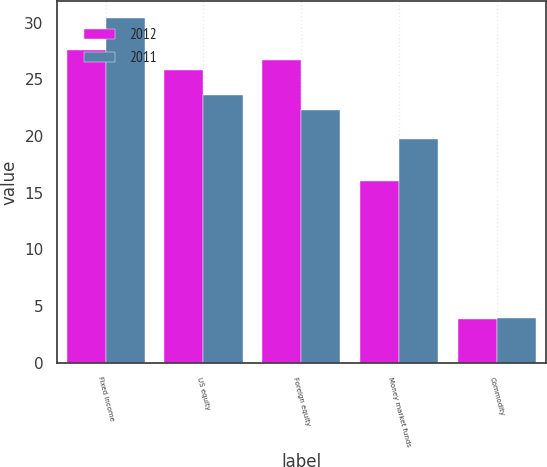Convert chart to OTSL. <chart><loc_0><loc_0><loc_500><loc_500><stacked_bar_chart><ecel><fcel>Fixed income<fcel>US equity<fcel>Foreign equity<fcel>Money market funds<fcel>Commodity<nl><fcel>2012<fcel>27.6<fcel>25.8<fcel>26.7<fcel>16<fcel>3.9<nl><fcel>2011<fcel>30.4<fcel>23.6<fcel>22.3<fcel>19.7<fcel>4<nl></chart> 